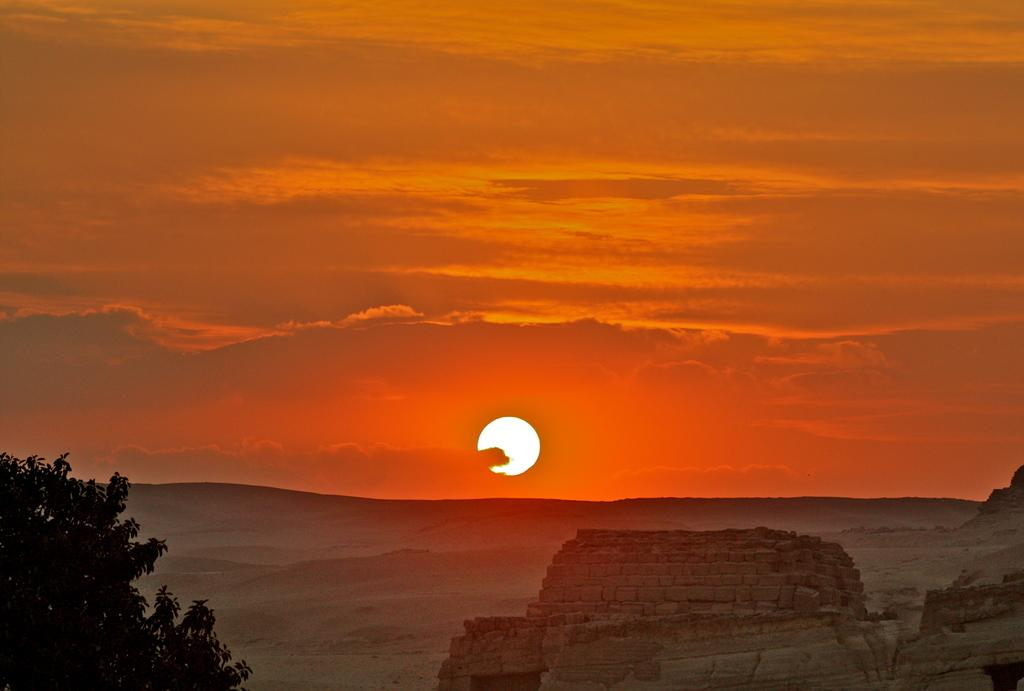What type of natural formation can be seen in the image? There are mountains in the image. Where is the tree located in the image? The tree is in the bottom left corner of the image. What part of the natural environment is visible in the image? The ground and the sky are visible in the image. What can be seen in the sky in the image? Clouds and the sun are present in the sky. What type of music can be heard coming from the mountains in the image? There is no music present in the image, as it features mountains, a tree, the ground, the sky, clouds, and the sun. Where is the spot located in the image? There is no specific spot mentioned or visible in the image. 